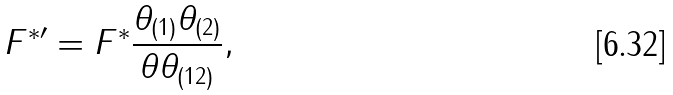<formula> <loc_0><loc_0><loc_500><loc_500>F ^ { * \prime } = F ^ { * } \frac { \theta _ { ( 1 ) } \theta _ { ( 2 ) } } { \theta \theta _ { ( 1 2 ) } } ,</formula> 